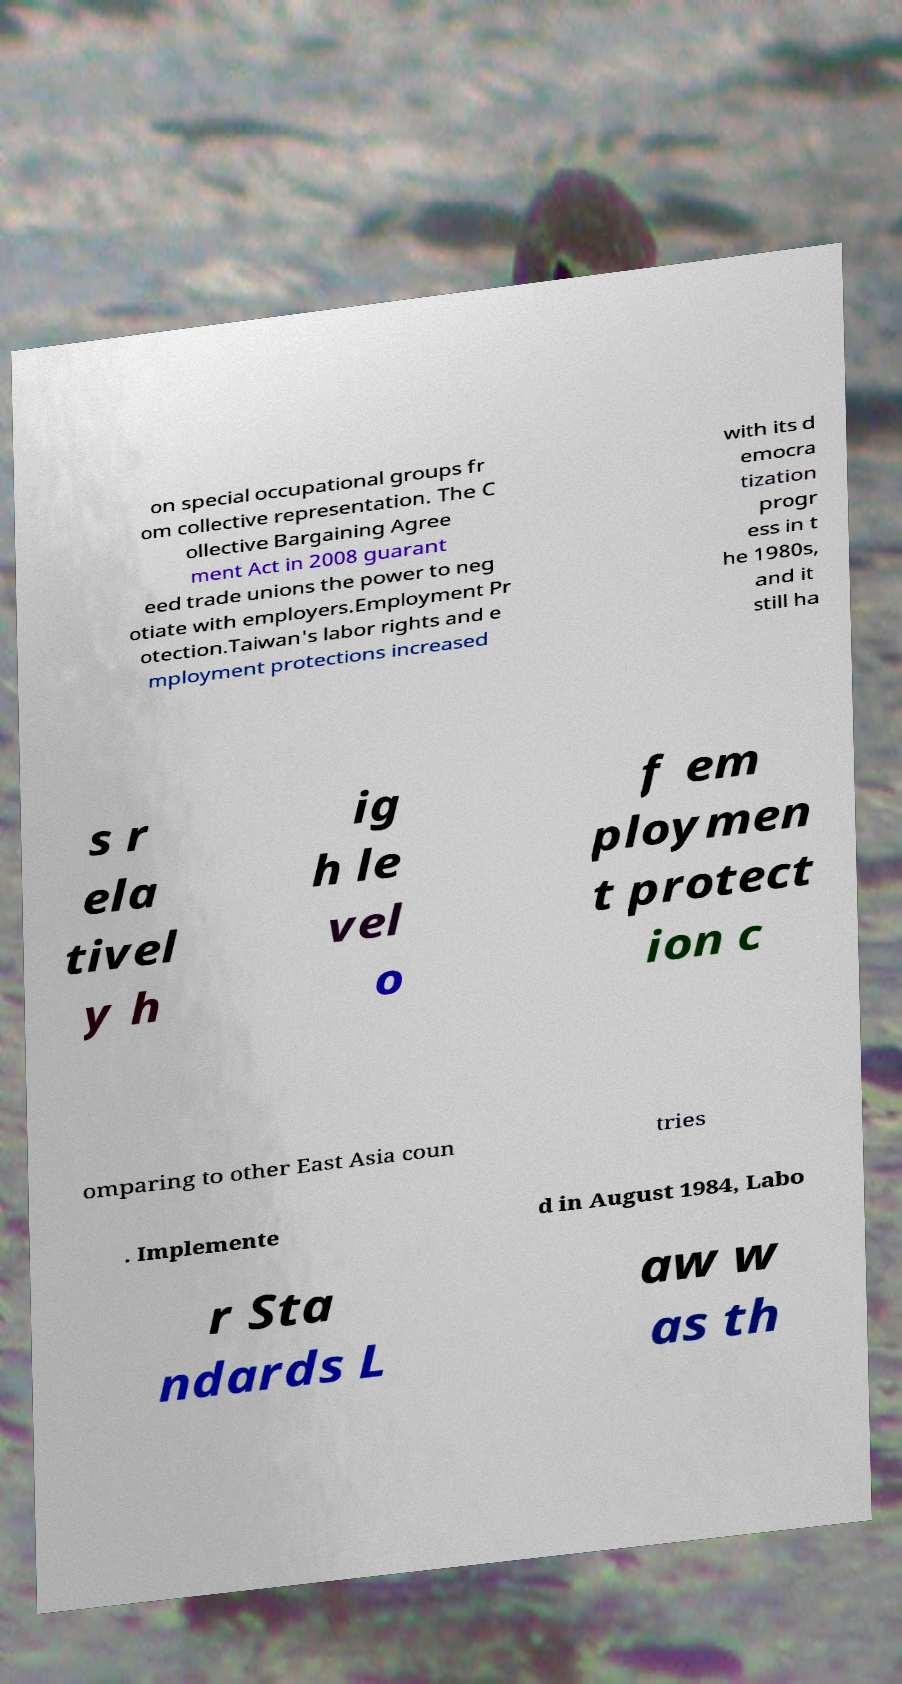What messages or text are displayed in this image? I need them in a readable, typed format. on special occupational groups fr om collective representation. The C ollective Bargaining Agree ment Act in 2008 guarant eed trade unions the power to neg otiate with employers.Employment Pr otection.Taiwan's labor rights and e mployment protections increased with its d emocra tization progr ess in t he 1980s, and it still ha s r ela tivel y h ig h le vel o f em ploymen t protect ion c omparing to other East Asia coun tries . Implemente d in August 1984, Labo r Sta ndards L aw w as th 